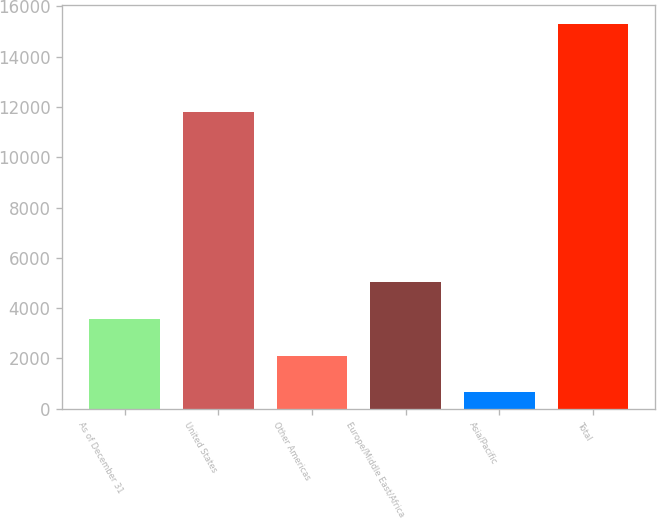Convert chart. <chart><loc_0><loc_0><loc_500><loc_500><bar_chart><fcel>As of December 31<fcel>United States<fcel>Other Americas<fcel>Europe/Middle East/Africa<fcel>Asia/Pacific<fcel>Total<nl><fcel>3576.6<fcel>11792<fcel>2111.3<fcel>5041.9<fcel>646<fcel>15299<nl></chart> 